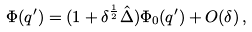<formula> <loc_0><loc_0><loc_500><loc_500>\Phi ( q ^ { \prime } ) = ( 1 + \delta ^ { \frac { 1 } { 2 } } \hat { \Delta } ) \Phi _ { 0 } ( q ^ { \prime } ) + O ( \delta ) \, ,</formula> 